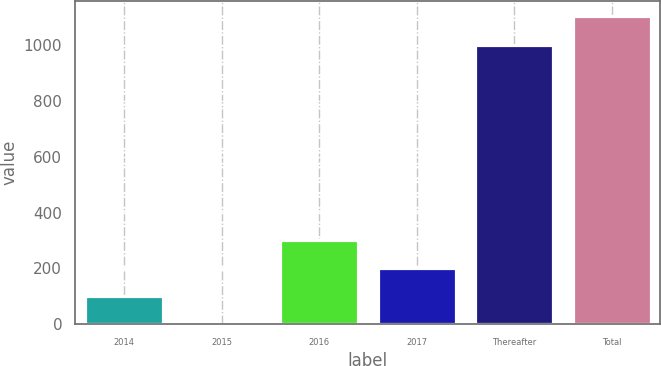Convert chart. <chart><loc_0><loc_0><loc_500><loc_500><bar_chart><fcel>2014<fcel>2015<fcel>2016<fcel>2017<fcel>Thereafter<fcel>Total<nl><fcel>101.59<fcel>0.6<fcel>303.57<fcel>202.58<fcel>1000.5<fcel>1101.49<nl></chart> 